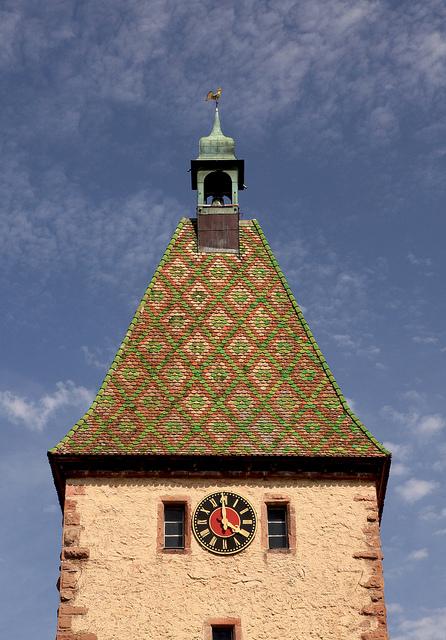Is the roof patterned?
Short answer required. Yes. What color is the center of the clock?
Write a very short answer. Red. What time does the clock have?
Short answer required. 4:00. 